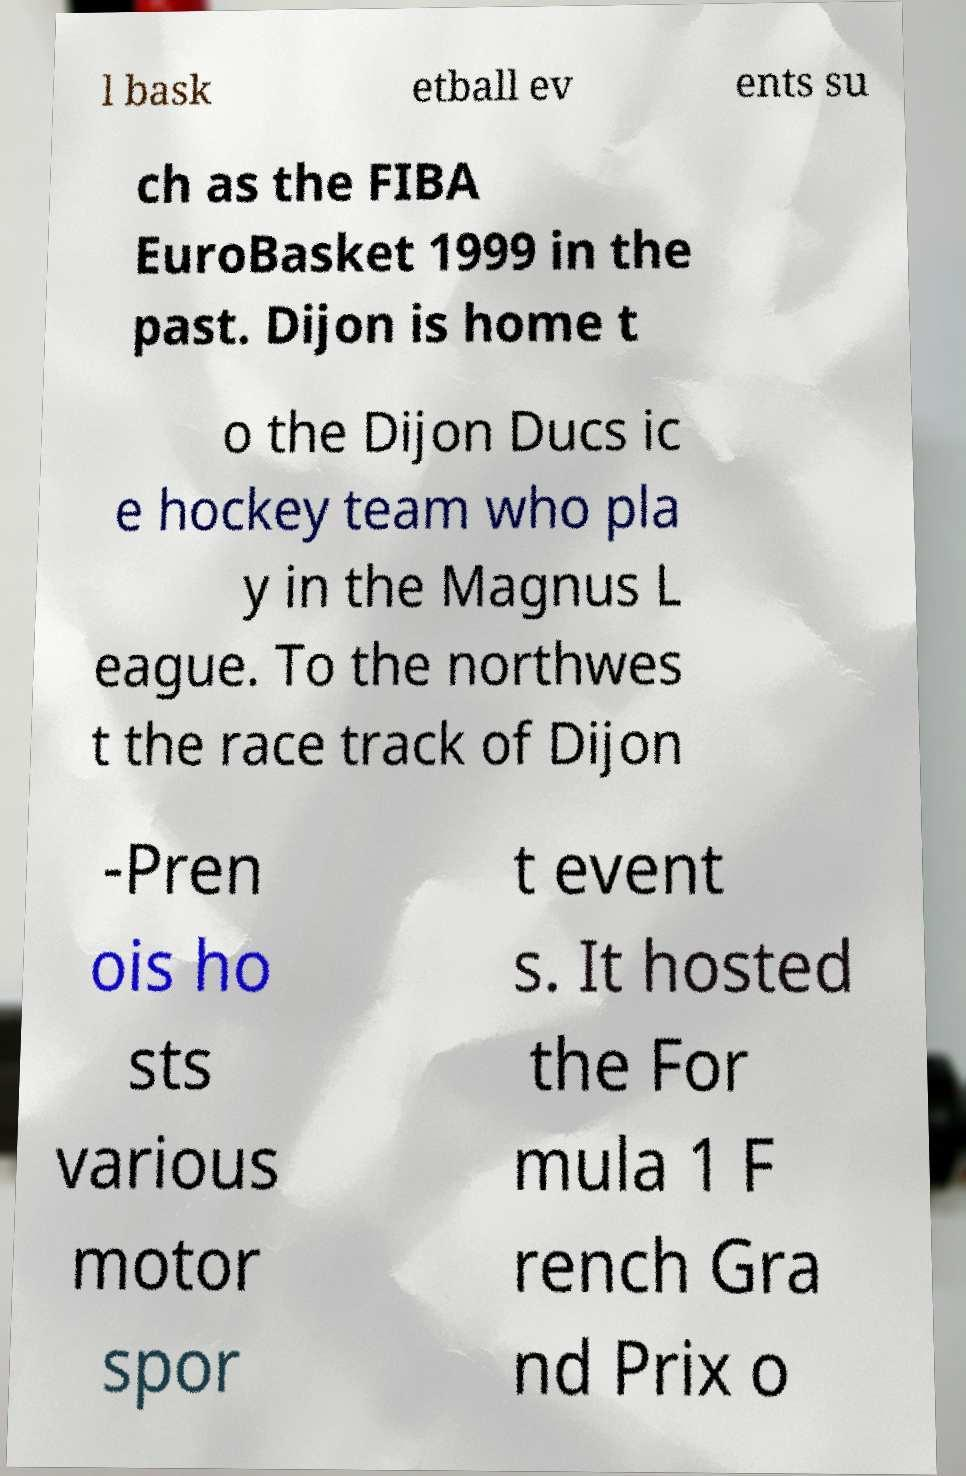Please read and relay the text visible in this image. What does it say? l bask etball ev ents su ch as the FIBA EuroBasket 1999 in the past. Dijon is home t o the Dijon Ducs ic e hockey team who pla y in the Magnus L eague. To the northwes t the race track of Dijon -Pren ois ho sts various motor spor t event s. It hosted the For mula 1 F rench Gra nd Prix o 